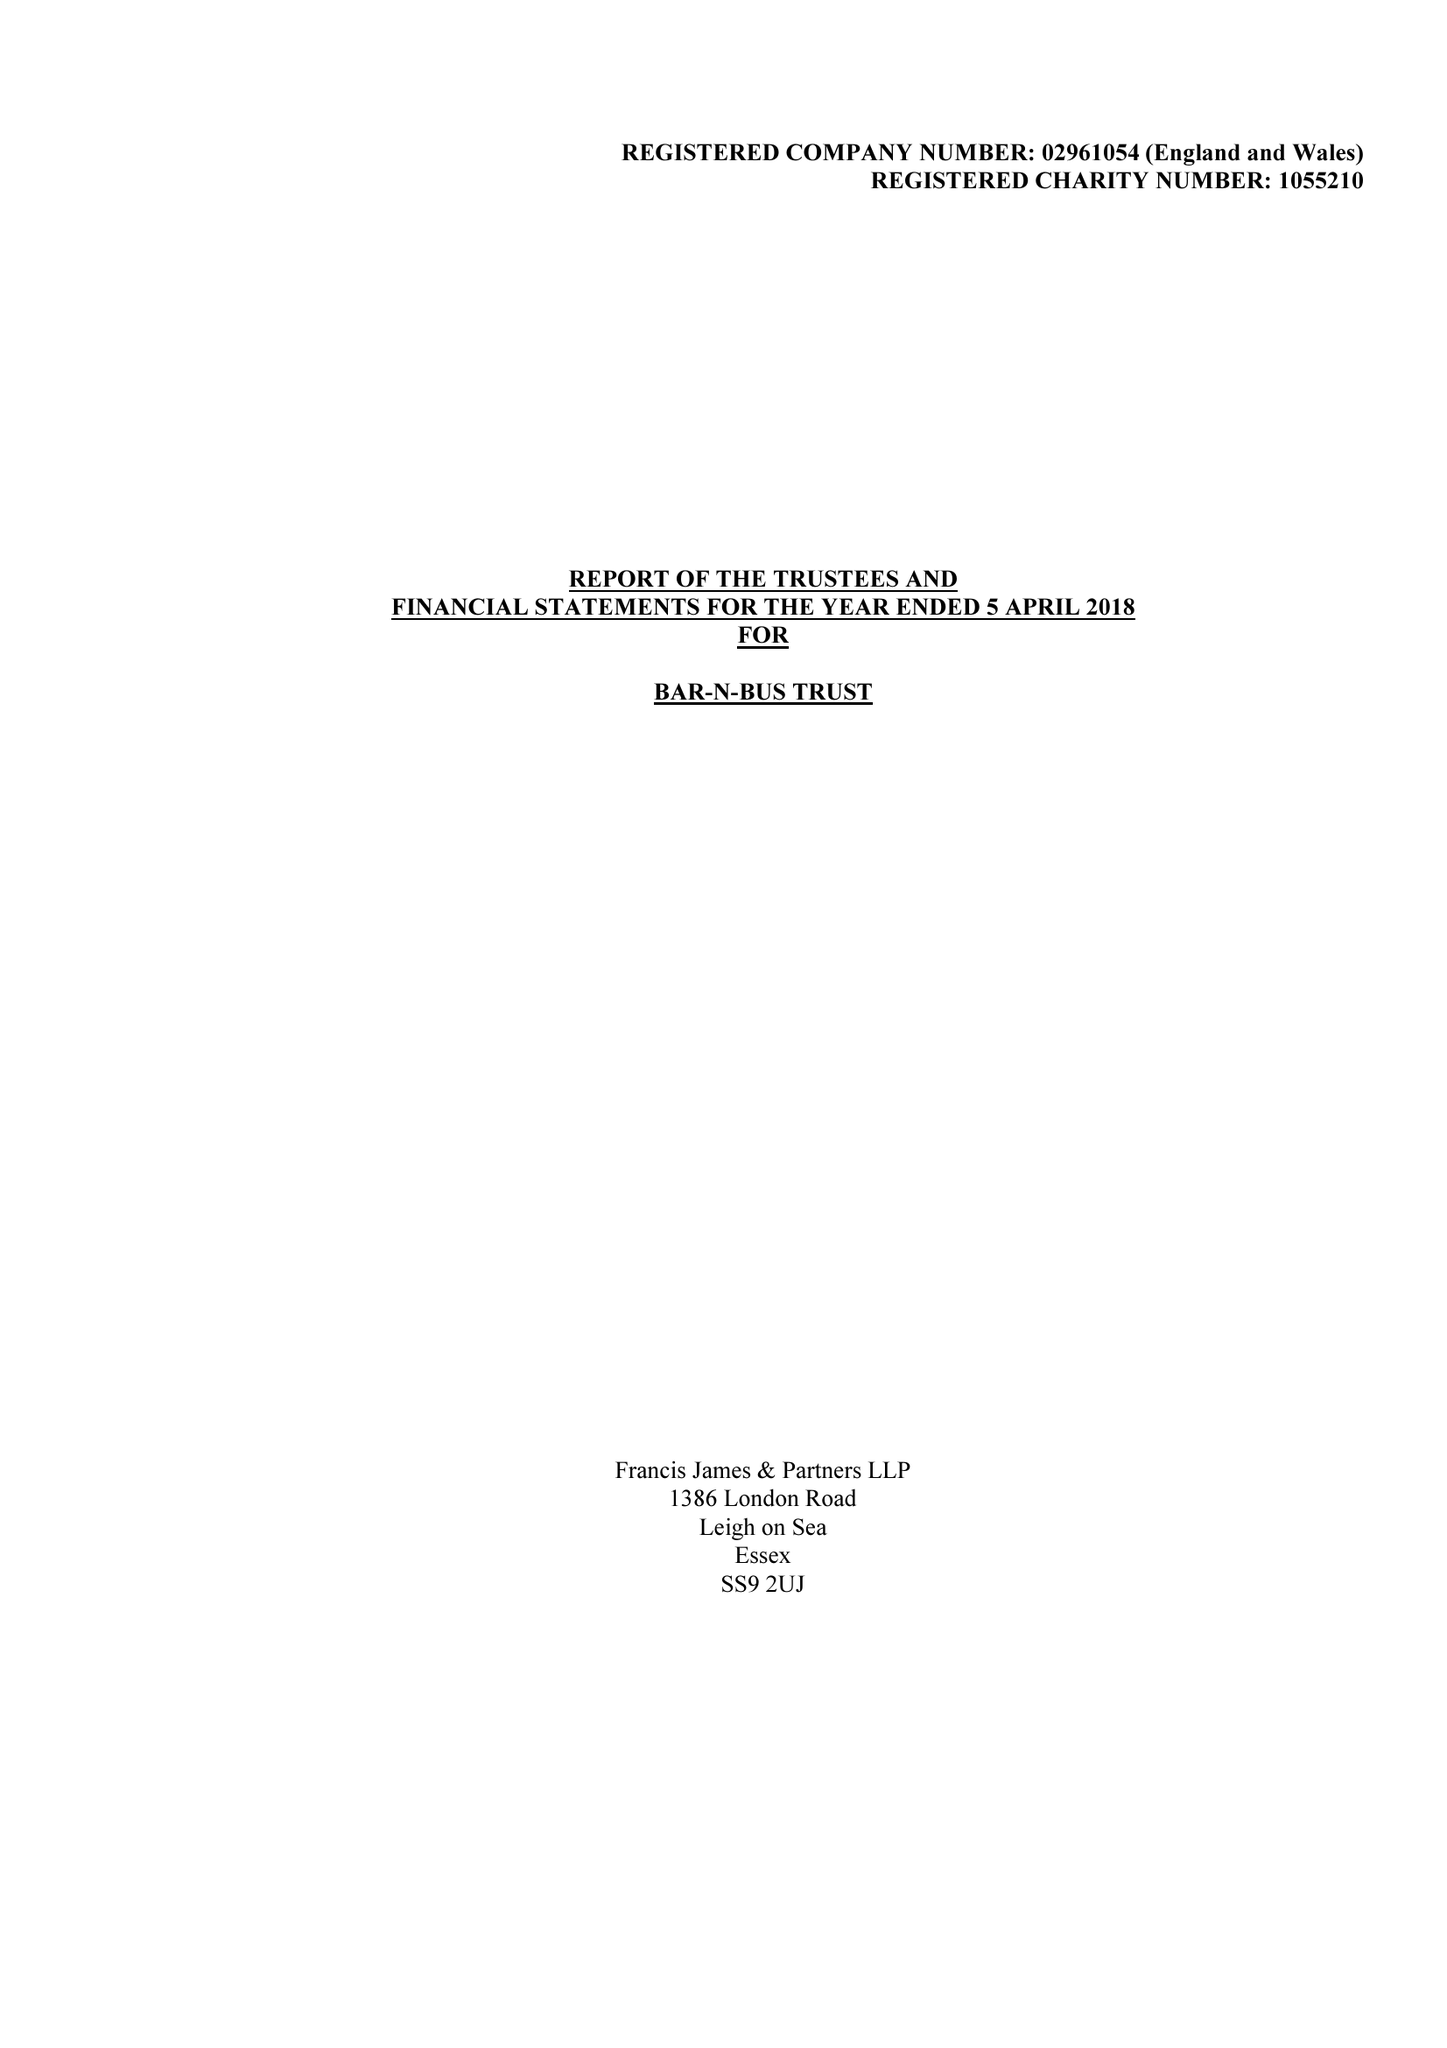What is the value for the charity_number?
Answer the question using a single word or phrase. 1055210 